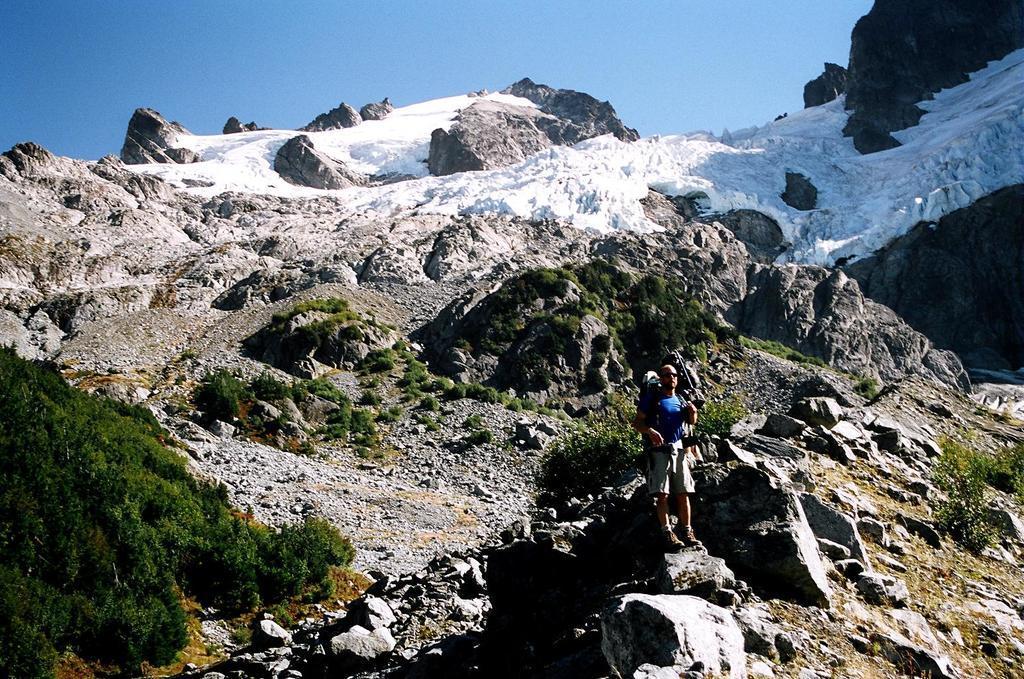Can you describe this image briefly? In this picture there is a person standing on the mountain and there are plants and there is snow on the mountain. At the top there is sky. 